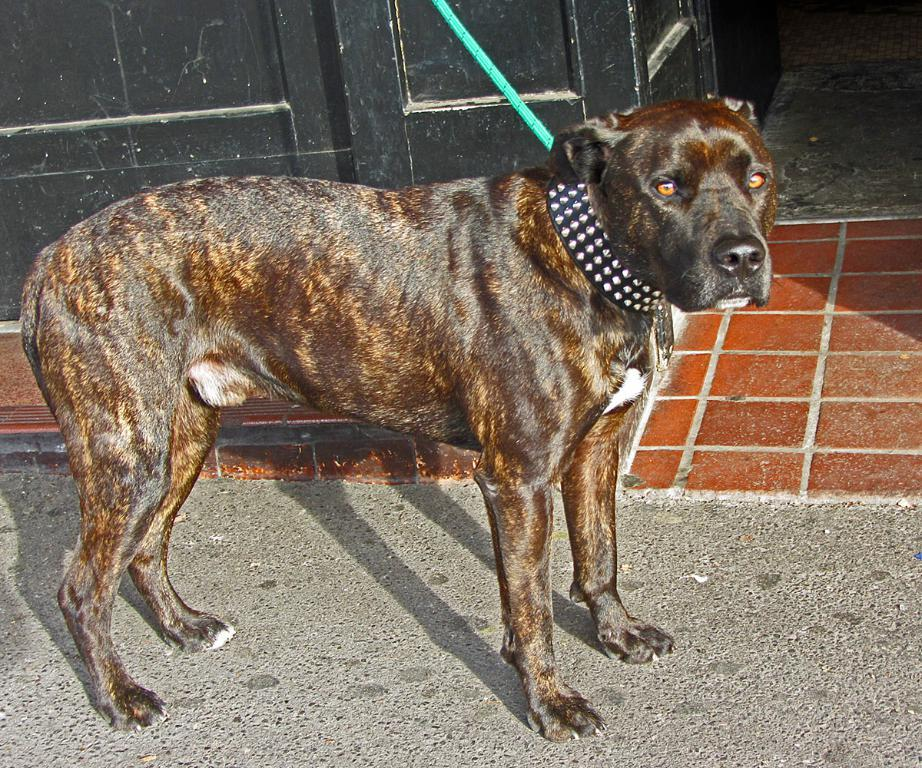What type of animal is in the image? There is a brown color dog in the image. How is the dog secured in the image? The dog is tied using a chain. Where is the dog located in the image? The dog is standing on the road. What can be seen in the background of the image? There is a black color wall and brown color tiles in the background of the image. What type of straw is the dog chewing on in the image? There is no straw present in the image; the dog is simply standing on the road, tied using a chain. 